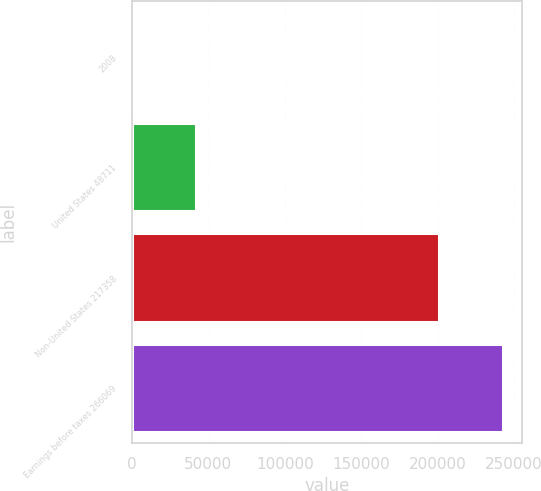<chart> <loc_0><loc_0><loc_500><loc_500><bar_chart><fcel>2008<fcel>United States 48711<fcel>Non-United States 217358<fcel>Earnings before taxes 266069<nl><fcel>2007<fcel>41970<fcel>200897<fcel>242867<nl></chart> 